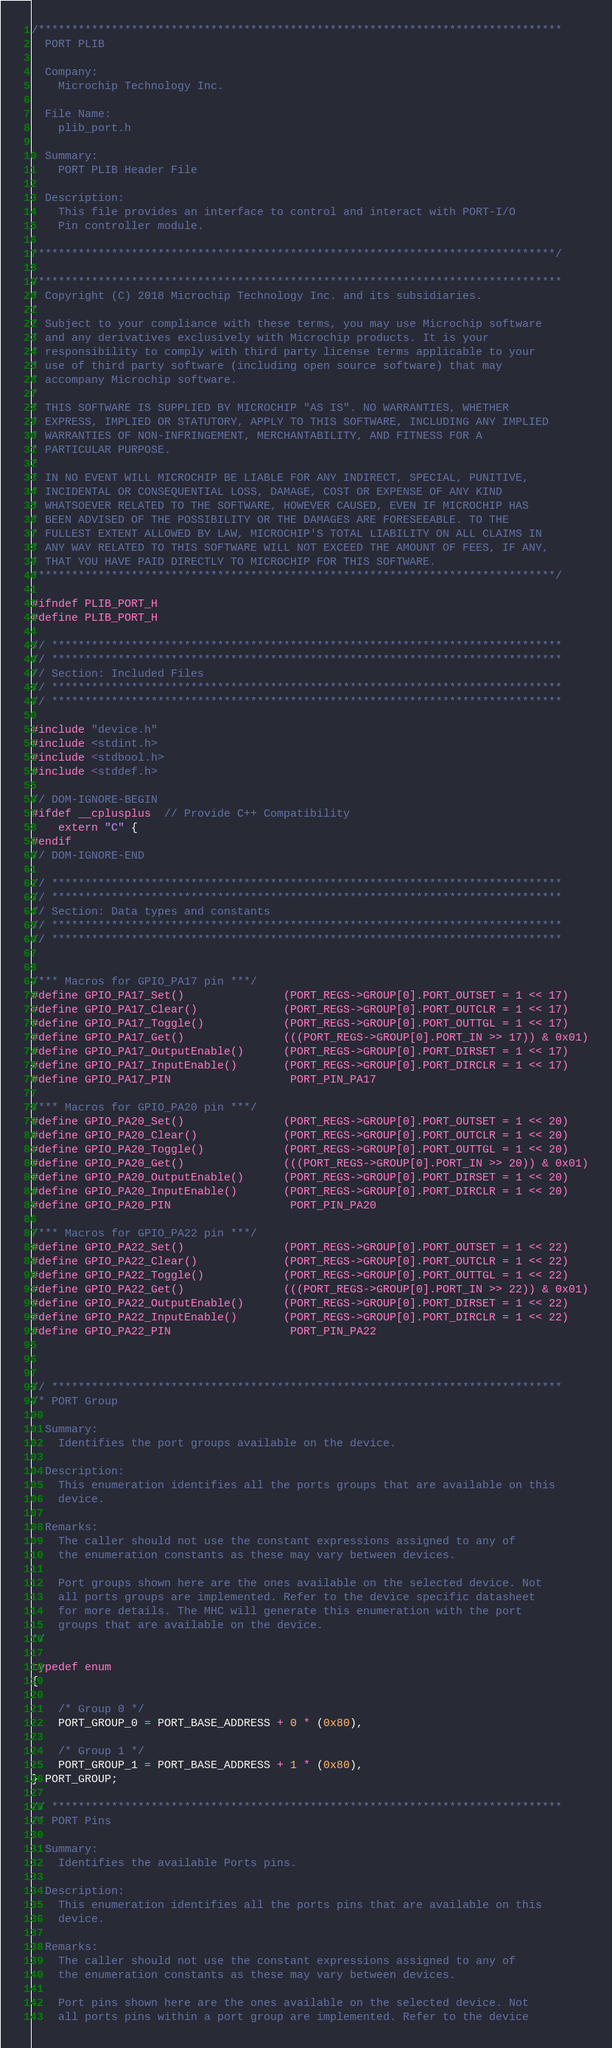Convert code to text. <code><loc_0><loc_0><loc_500><loc_500><_C_>/*******************************************************************************
  PORT PLIB

  Company:
    Microchip Technology Inc.

  File Name:
    plib_port.h

  Summary:
    PORT PLIB Header File

  Description:
    This file provides an interface to control and interact with PORT-I/O
    Pin controller module.

*******************************************************************************/

/*******************************************************************************
* Copyright (C) 2018 Microchip Technology Inc. and its subsidiaries.
*
* Subject to your compliance with these terms, you may use Microchip software
* and any derivatives exclusively with Microchip products. It is your
* responsibility to comply with third party license terms applicable to your
* use of third party software (including open source software) that may
* accompany Microchip software.
*
* THIS SOFTWARE IS SUPPLIED BY MICROCHIP "AS IS". NO WARRANTIES, WHETHER
* EXPRESS, IMPLIED OR STATUTORY, APPLY TO THIS SOFTWARE, INCLUDING ANY IMPLIED
* WARRANTIES OF NON-INFRINGEMENT, MERCHANTABILITY, AND FITNESS FOR A
* PARTICULAR PURPOSE.
*
* IN NO EVENT WILL MICROCHIP BE LIABLE FOR ANY INDIRECT, SPECIAL, PUNITIVE,
* INCIDENTAL OR CONSEQUENTIAL LOSS, DAMAGE, COST OR EXPENSE OF ANY KIND
* WHATSOEVER RELATED TO THE SOFTWARE, HOWEVER CAUSED, EVEN IF MICROCHIP HAS
* BEEN ADVISED OF THE POSSIBILITY OR THE DAMAGES ARE FORESEEABLE. TO THE
* FULLEST EXTENT ALLOWED BY LAW, MICROCHIP'S TOTAL LIABILITY ON ALL CLAIMS IN
* ANY WAY RELATED TO THIS SOFTWARE WILL NOT EXCEED THE AMOUNT OF FEES, IF ANY,
* THAT YOU HAVE PAID DIRECTLY TO MICROCHIP FOR THIS SOFTWARE.
*******************************************************************************/

#ifndef PLIB_PORT_H
#define PLIB_PORT_H

// *****************************************************************************
// *****************************************************************************
// Section: Included Files
// *****************************************************************************
// *****************************************************************************

#include "device.h"
#include <stdint.h>
#include <stdbool.h>
#include <stddef.h>

// DOM-IGNORE-BEGIN
#ifdef __cplusplus  // Provide C++ Compatibility
    extern "C" {
#endif
// DOM-IGNORE-END

// *****************************************************************************
// *****************************************************************************
// Section: Data types and constants
// *****************************************************************************
// *****************************************************************************


/*** Macros for GPIO_PA17 pin ***/
#define GPIO_PA17_Set()               (PORT_REGS->GROUP[0].PORT_OUTSET = 1 << 17)
#define GPIO_PA17_Clear()             (PORT_REGS->GROUP[0].PORT_OUTCLR = 1 << 17)
#define GPIO_PA17_Toggle()            (PORT_REGS->GROUP[0].PORT_OUTTGL = 1 << 17)
#define GPIO_PA17_Get()               (((PORT_REGS->GROUP[0].PORT_IN >> 17)) & 0x01)
#define GPIO_PA17_OutputEnable()      (PORT_REGS->GROUP[0].PORT_DIRSET = 1 << 17)
#define GPIO_PA17_InputEnable()       (PORT_REGS->GROUP[0].PORT_DIRCLR = 1 << 17)
#define GPIO_PA17_PIN                  PORT_PIN_PA17

/*** Macros for GPIO_PA20 pin ***/
#define GPIO_PA20_Set()               (PORT_REGS->GROUP[0].PORT_OUTSET = 1 << 20)
#define GPIO_PA20_Clear()             (PORT_REGS->GROUP[0].PORT_OUTCLR = 1 << 20)
#define GPIO_PA20_Toggle()            (PORT_REGS->GROUP[0].PORT_OUTTGL = 1 << 20)
#define GPIO_PA20_Get()               (((PORT_REGS->GROUP[0].PORT_IN >> 20)) & 0x01)
#define GPIO_PA20_OutputEnable()      (PORT_REGS->GROUP[0].PORT_DIRSET = 1 << 20)
#define GPIO_PA20_InputEnable()       (PORT_REGS->GROUP[0].PORT_DIRCLR = 1 << 20)
#define GPIO_PA20_PIN                  PORT_PIN_PA20

/*** Macros for GPIO_PA22 pin ***/
#define GPIO_PA22_Set()               (PORT_REGS->GROUP[0].PORT_OUTSET = 1 << 22)
#define GPIO_PA22_Clear()             (PORT_REGS->GROUP[0].PORT_OUTCLR = 1 << 22)
#define GPIO_PA22_Toggle()            (PORT_REGS->GROUP[0].PORT_OUTTGL = 1 << 22)
#define GPIO_PA22_Get()               (((PORT_REGS->GROUP[0].PORT_IN >> 22)) & 0x01)
#define GPIO_PA22_OutputEnable()      (PORT_REGS->GROUP[0].PORT_DIRSET = 1 << 22)
#define GPIO_PA22_InputEnable()       (PORT_REGS->GROUP[0].PORT_DIRCLR = 1 << 22)
#define GPIO_PA22_PIN                  PORT_PIN_PA22



// *****************************************************************************
/* PORT Group

  Summary:
    Identifies the port groups available on the device.

  Description:
    This enumeration identifies all the ports groups that are available on this
    device.

  Remarks:
    The caller should not use the constant expressions assigned to any of
    the enumeration constants as these may vary between devices.

    Port groups shown here are the ones available on the selected device. Not
    all ports groups are implemented. Refer to the device specific datasheet
    for more details. The MHC will generate this enumeration with the port
    groups that are available on the device.
*/

typedef enum
{

    /* Group 0 */
    PORT_GROUP_0 = PORT_BASE_ADDRESS + 0 * (0x80),

    /* Group 1 */
    PORT_GROUP_1 = PORT_BASE_ADDRESS + 1 * (0x80),
} PORT_GROUP;

// *****************************************************************************
/* PORT Pins

  Summary:
    Identifies the available Ports pins.

  Description:
    This enumeration identifies all the ports pins that are available on this
    device.

  Remarks:
    The caller should not use the constant expressions assigned to any of
    the enumeration constants as these may vary between devices.

    Port pins shown here are the ones available on the selected device. Not
    all ports pins within a port group are implemented. Refer to the device</code> 